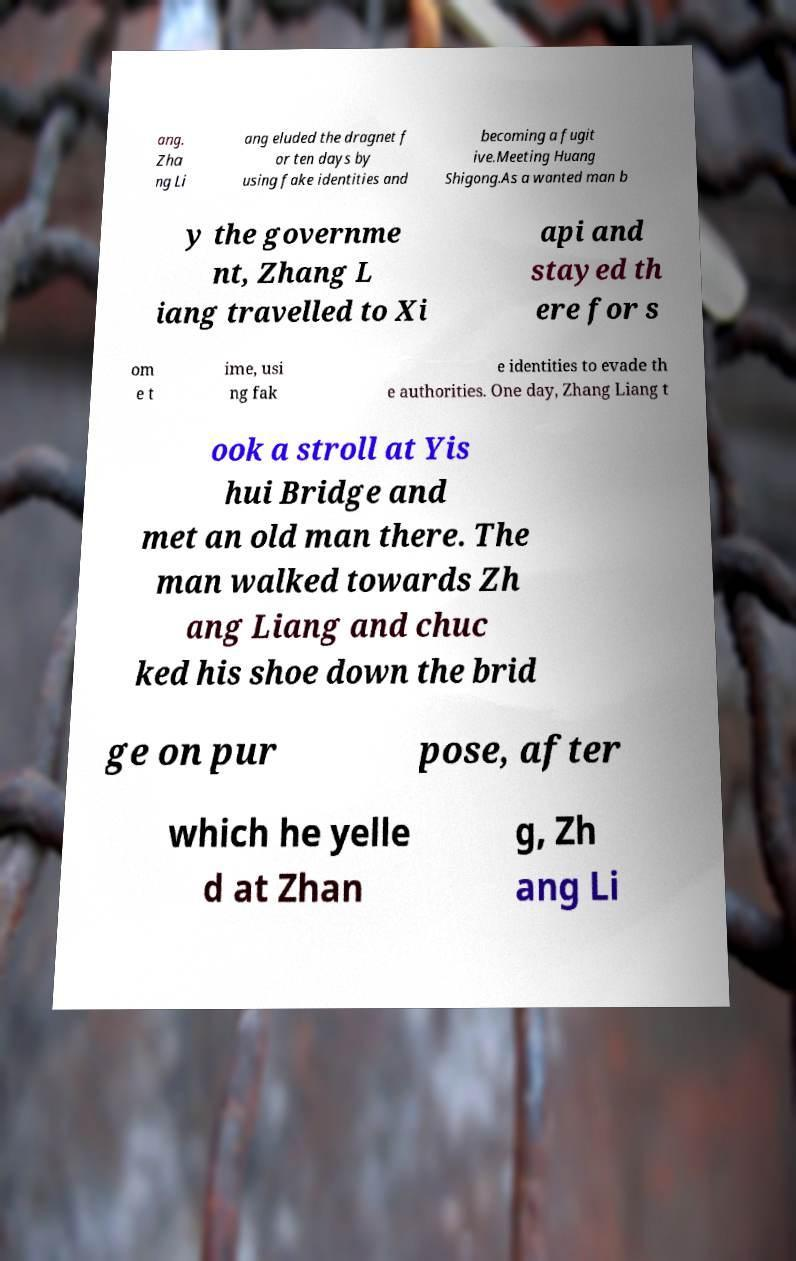There's text embedded in this image that I need extracted. Can you transcribe it verbatim? ang. Zha ng Li ang eluded the dragnet f or ten days by using fake identities and becoming a fugit ive.Meeting Huang Shigong.As a wanted man b y the governme nt, Zhang L iang travelled to Xi api and stayed th ere for s om e t ime, usi ng fak e identities to evade th e authorities. One day, Zhang Liang t ook a stroll at Yis hui Bridge and met an old man there. The man walked towards Zh ang Liang and chuc ked his shoe down the brid ge on pur pose, after which he yelle d at Zhan g, Zh ang Li 